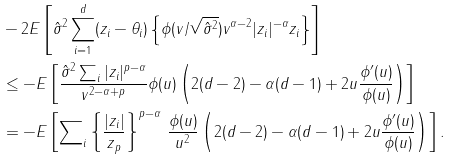Convert formula to latex. <formula><loc_0><loc_0><loc_500><loc_500>& - 2 E \left [ \hat { \sigma } ^ { 2 } \sum _ { i = 1 } ^ { d } ( z _ { i } - \theta _ { i } ) \left \{ \phi ( v / \sqrt { \hat { \sigma } ^ { 2 } } ) v ^ { \alpha - 2 } | z _ { i } | ^ { - \alpha } z _ { i } \right \} \right ] \\ & \leq - E \left [ \frac { \hat { \sigma } ^ { 2 } \sum \nolimits _ { i } | z _ { i } | ^ { p - \alpha } } { v ^ { 2 - \alpha + p } } \phi ( u ) \left ( 2 ( d - 2 ) - \alpha ( d - 1 ) + 2 u \frac { \phi ^ { \prime } ( u ) } { \phi ( u ) } \right ) \right ] \\ & = - E \left [ \sum \nolimits _ { i } \left \{ \frac { | z _ { i } | } { \| z \| _ { p } } \right \} ^ { p - \alpha } \, \frac { \phi ( u ) } { u ^ { 2 } } \left ( 2 ( d - 2 ) - \alpha ( d - 1 ) + 2 u \frac { \phi ^ { \prime } ( u ) } { \phi ( u ) } \right ) \right ] .</formula> 